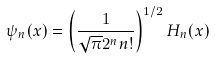<formula> <loc_0><loc_0><loc_500><loc_500>\psi _ { n } ( x ) = \left ( \frac { 1 } { \sqrt { \pi } 2 ^ { n } n ! } \right ) ^ { 1 / 2 } H _ { n } ( x )</formula> 